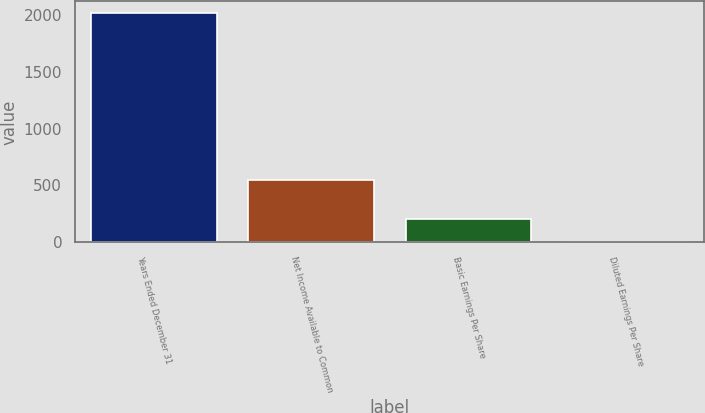<chart> <loc_0><loc_0><loc_500><loc_500><bar_chart><fcel>Years Ended December 31<fcel>Net Income Available to Common<fcel>Basic Earnings Per Share<fcel>Diluted Earnings Per Share<nl><fcel>2016<fcel>551<fcel>203.38<fcel>1.98<nl></chart> 